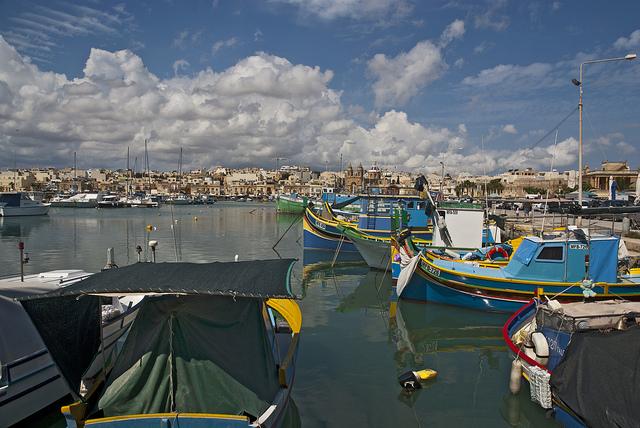Are there clouds in the sky?
Give a very brief answer. Yes. Is the water blue in the picture?
Answer briefly. No. Is this a parking lot?
Keep it brief. No. What color is the boat closest to the camera?
Give a very brief answer. Blue. 